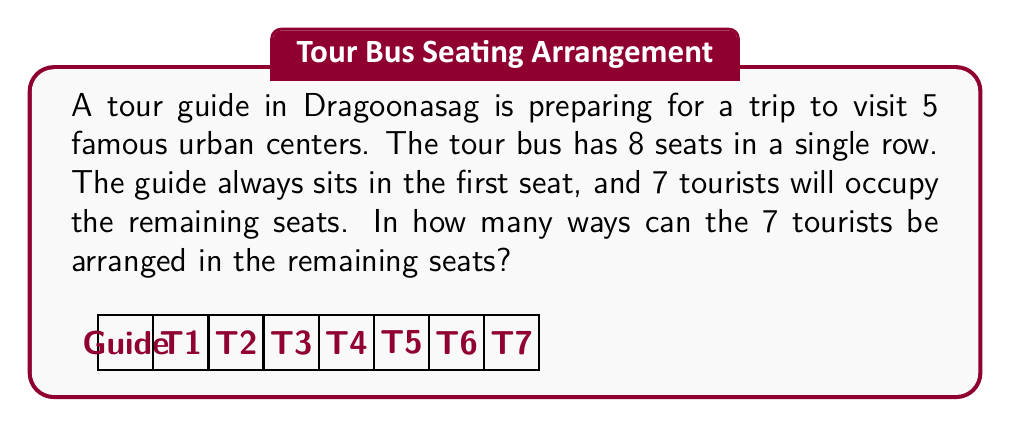Help me with this question. Let's approach this step-by-step:

1) First, we need to recognize that this is a permutation problem. We are arranging 7 tourists in 7 seats (remember, the guide always sits in the first seat).

2) The formula for permutations is:

   $$P(n,r) = n!$$

   Where $n$ is the number of objects to be arranged, and $r$ is the number of positions (in this case, $n = r = 7$).

3) Therefore, we can calculate the number of arrangements as follows:

   $$7! = 7 \times 6 \times 5 \times 4 \times 3 \times 2 \times 1$$

4) Let's compute this:

   $$7! = 7 \times 6 \times 5 \times 4 \times 3 \times 2 \times 1 = 5040$$

5) Thus, there are 5040 possible ways to arrange the 7 tourists in the 7 remaining seats.

This large number of possibilities highlights the complexity of seating arrangements even for a relatively small group, which could be an interesting point for the tour guide to mention to the tourists!
Answer: $5040$ 